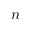Convert formula to latex. <formula><loc_0><loc_0><loc_500><loc_500>n</formula> 